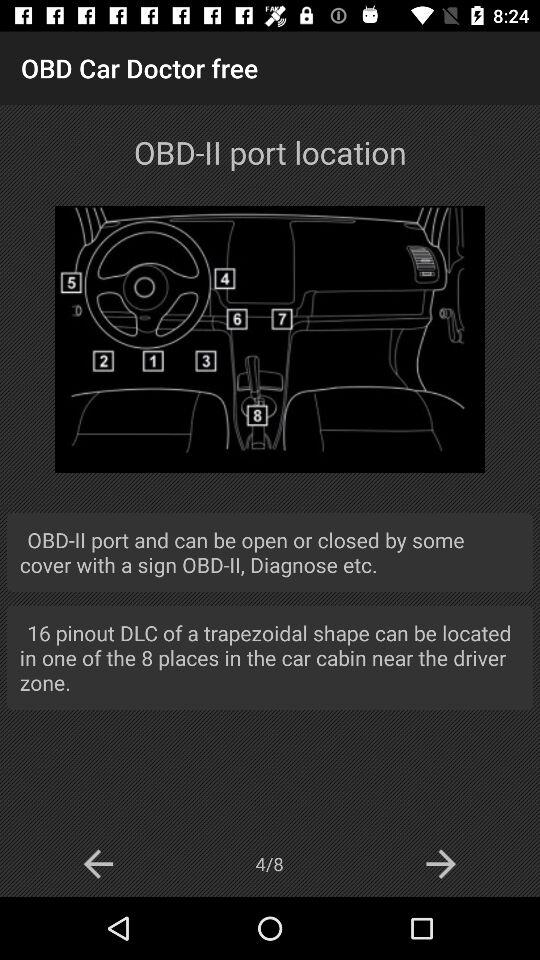On which page are we now? Now, you are on page 4. 